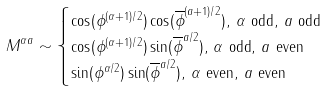<formula> <loc_0><loc_0><loc_500><loc_500>M ^ { \alpha a } & \sim \begin{cases} \cos ( \phi ^ { ( \alpha + 1 ) / 2 } ) \cos ( \overline { \phi } ^ { ( a + 1 ) / 2 } ) , \, \alpha \text { odd} , \, a \text { odd} \\ \cos ( \phi ^ { ( \alpha + 1 ) / 2 } ) \sin ( \overline { \phi } ^ { a / 2 } ) , \, \alpha \text { odd} , \, a \text { even} \\ \sin ( \phi ^ { \alpha / 2 } ) \sin ( \overline { \phi } ^ { a / 2 } ) , \, \alpha \text { even} , \, a \text { even} \end{cases}</formula> 